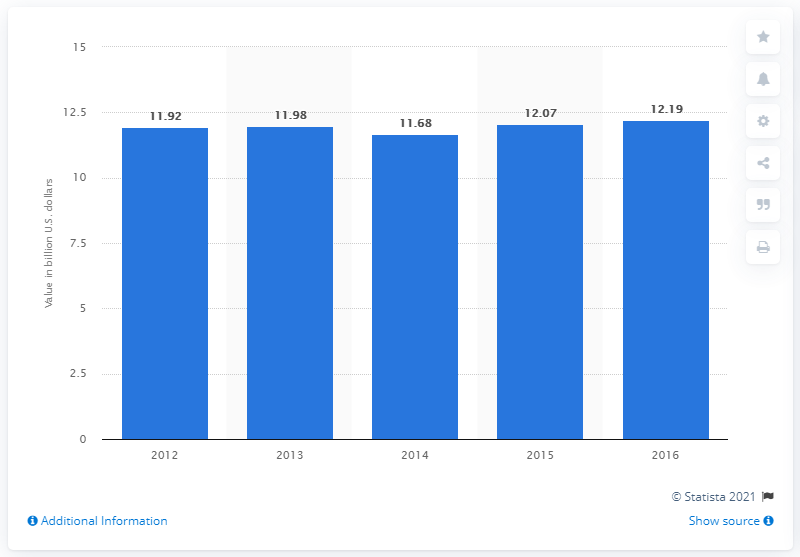Give some essential details in this illustration. In 2016, the value of dry pasta shipments in the United States was 12.19 billion dollars. 